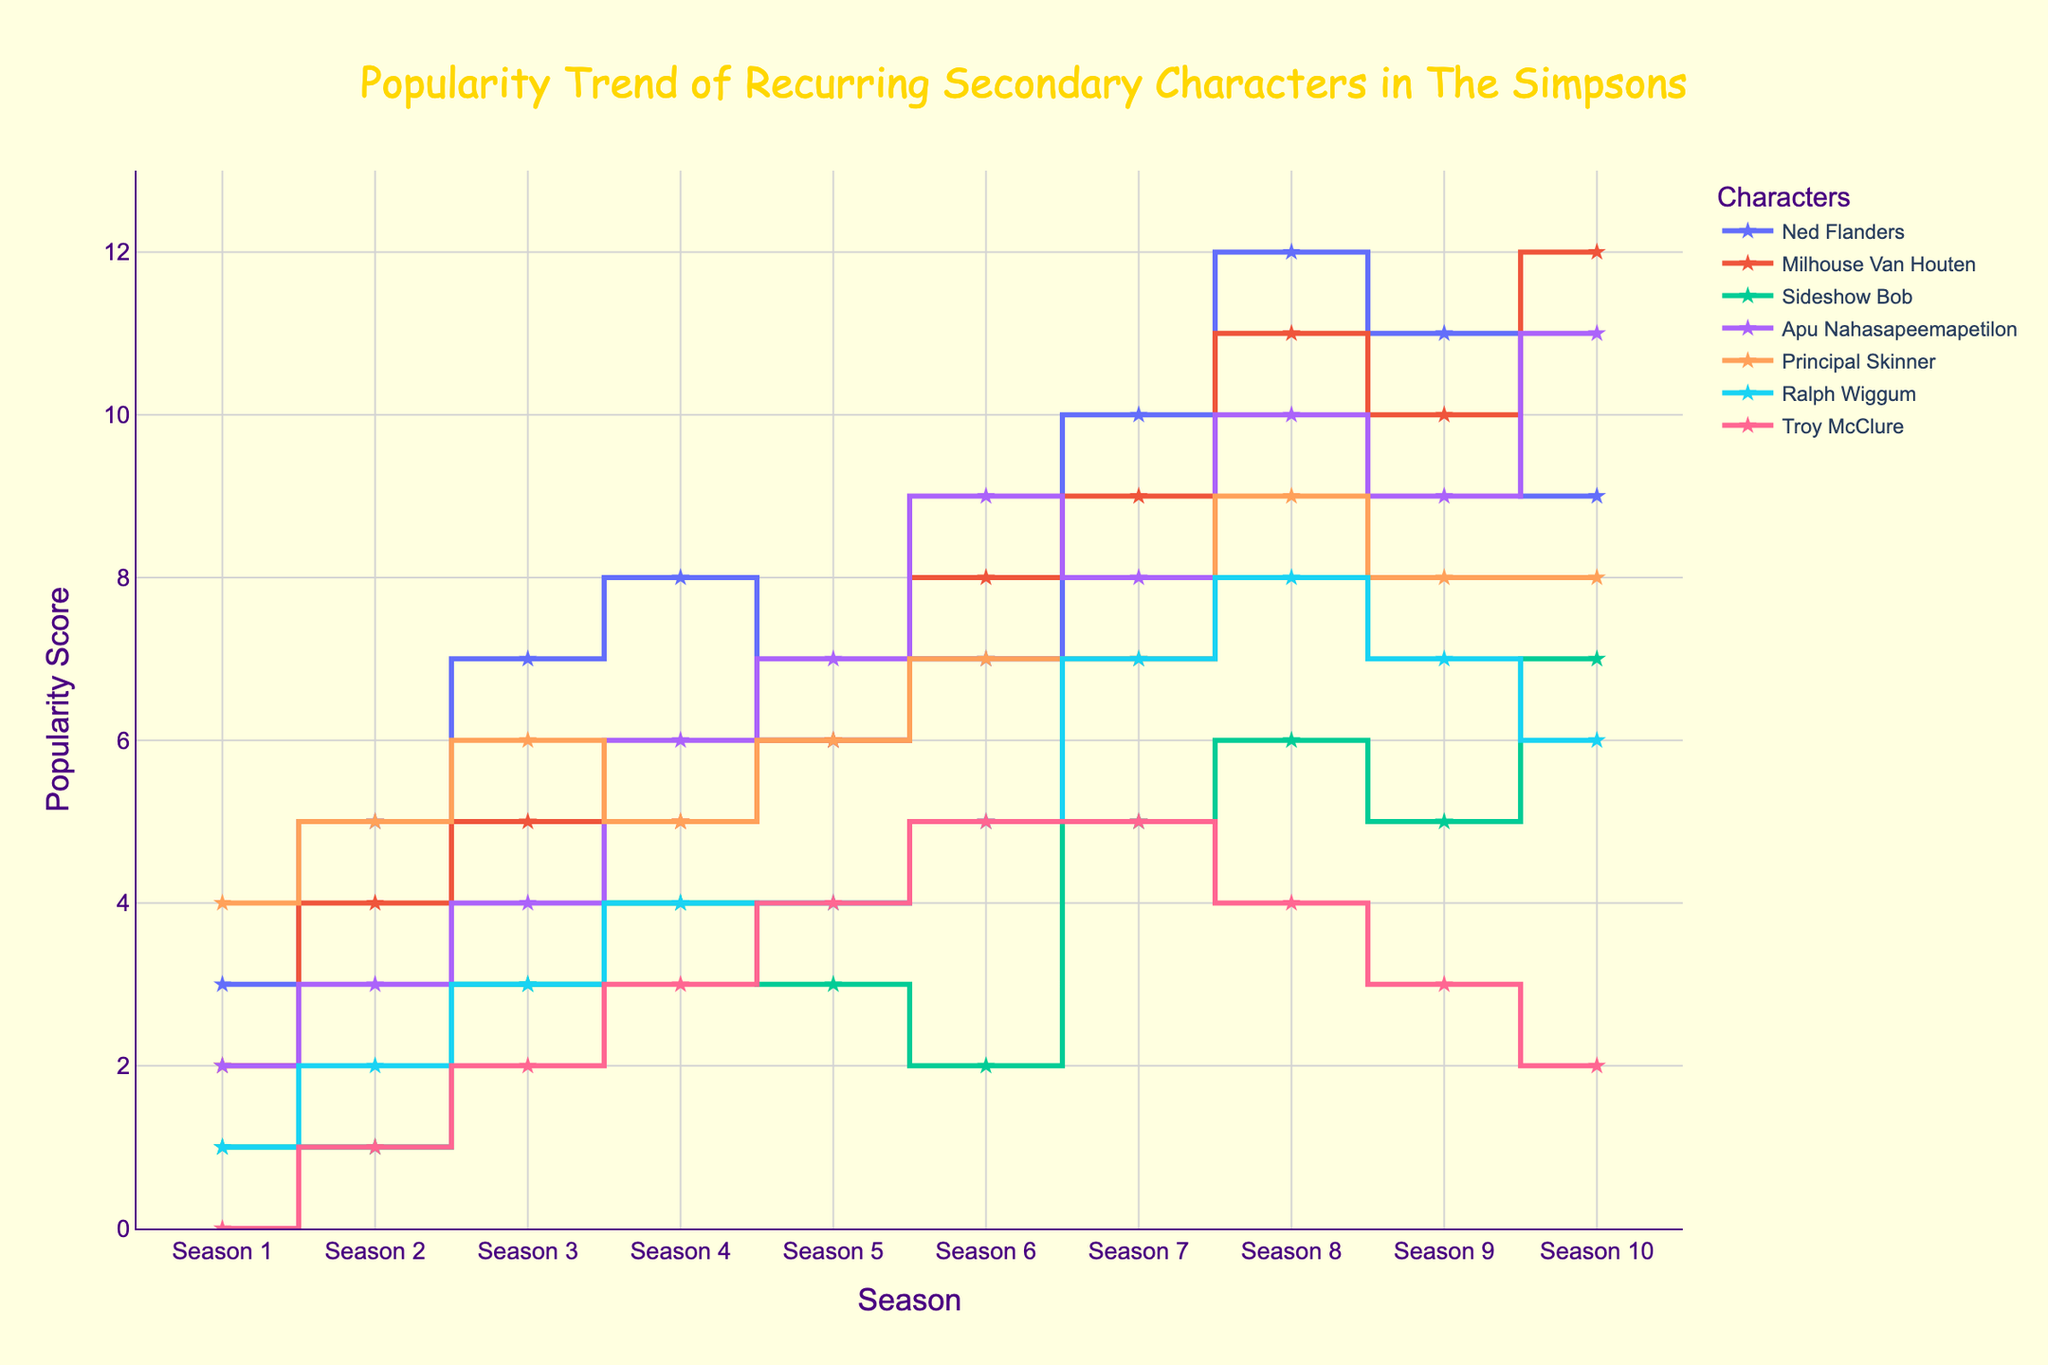What is the title of the plot? The title is displayed at the top center of the plot.
Answer: Popularity Trend of Recurring Secondary Characters in The Simpsons Which character had the highest popularity score in Season 10? Look for the highest point on the y-axis within the Season 10 column.
Answer: Milhouse Van Houten How many seasons are depicted in the plot? Count the number of unique labeled points along the x-axis.
Answer: 10 Which character had a constant decrease in popularity starting from Season 6? Identify the character whose line consistently goes downwards from Season 6 onwards.
Answer: Troy McClure Between Season 2 and Season 5, which character shows the second highest increase in popularity? Calculate the difference in popularity scores between Season 2 and Season 5 for each character. Compare the differences.
Answer: Apu Nahasapeemapetilon Which character's popularity score decreased the most between two consecutive seasons? Identify the largest downward step in the plot across all characters and seasons.
Answer: Principal Skinner (Season 8 to Season 9) Which characters had a popularity score of 7 in Season 7? Look at the y-axis values for Season 7 and identify the characters at the specific point.
Answer: Ned Flanders, Principal Skinner, and Ralph Wiggum Which character shows a linear increase in popularity across all seasons? Find the character whose line consistently goes upwards with an equal increase each season.
Answer: Milhouse Van Houten Who had a higher popularity score in Season 4: Sideshow Bob or Troy McClure? Compare their y-axis values for Season 4.
Answer: Sideshow Bob What is the range of popularity scores displayed on the y-axis? Identify the minimum and maximum values on the y-axis.
Answer: 0 to 13 